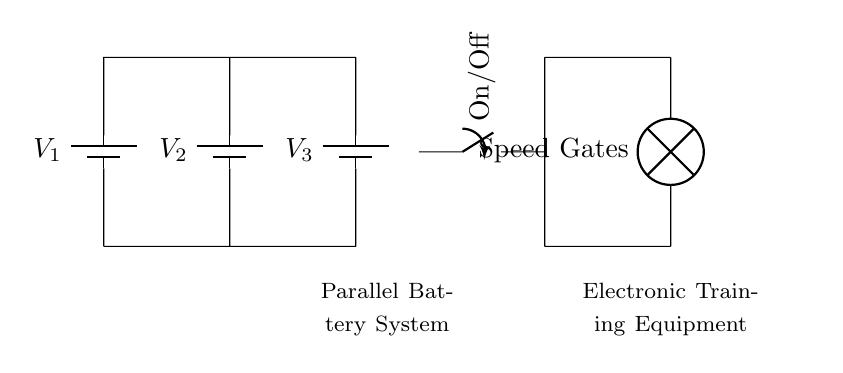What are the components used in the circuit? The circuit contains three batteries, a switch, and a lamp labeled as speed gates. These are the main components used to create the parallel battery system.
Answer: batteries, switch, lamp What is the orientation of the batteries in the diagram? The batteries are drawn vertically in the circuit, showing that they are connected parallel to each other. The vertical positioning assists in visualizing the parallel configuration.
Answer: vertical How many batteries are included in the system? The circuit diagram includes three batteries labeled as V1, V2, and V3. The number of batteries is a crucial aspect of the parallel system, as they provide power to the equipment.
Answer: three What is the purpose of the switch in the circuit? The switch controls the flow of electricity to the electronic training equipment. When closed, it allows current to flow, enabling the lamp (speed gates) to function.
Answer: control power How does the current flow through the circuit? In a parallel circuit, current can flow through multiple paths. Each battery provides current independently to the load (lamp). The total current is the sum of the currents through each path.
Answer: multiple paths What is the advantage of using a parallel battery system for training equipment? The parallel configuration allows the voltage to remain the same while increasing the available current capacity, resulting in longer operational time and improved reliability for the portable training equipment.
Answer: higher capacity 